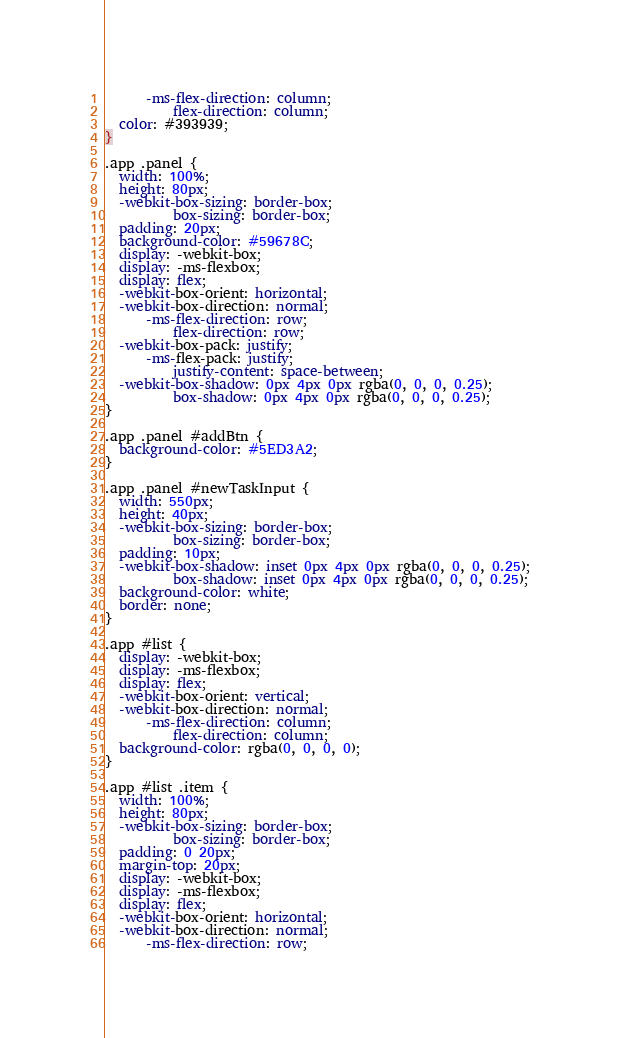<code> <loc_0><loc_0><loc_500><loc_500><_CSS_>      -ms-flex-direction: column;
          flex-direction: column;
  color: #393939;
}

.app .panel {
  width: 100%;
  height: 80px;
  -webkit-box-sizing: border-box;
          box-sizing: border-box;
  padding: 20px;
  background-color: #59678C;
  display: -webkit-box;
  display: -ms-flexbox;
  display: flex;
  -webkit-box-orient: horizontal;
  -webkit-box-direction: normal;
      -ms-flex-direction: row;
          flex-direction: row;
  -webkit-box-pack: justify;
      -ms-flex-pack: justify;
          justify-content: space-between;
  -webkit-box-shadow: 0px 4px 0px rgba(0, 0, 0, 0.25);
          box-shadow: 0px 4px 0px rgba(0, 0, 0, 0.25);
}

.app .panel #addBtn {
  background-color: #5ED3A2;
}

.app .panel #newTaskInput {
  width: 550px;
  height: 40px;
  -webkit-box-sizing: border-box;
          box-sizing: border-box;
  padding: 10px;
  -webkit-box-shadow: inset 0px 4px 0px rgba(0, 0, 0, 0.25);
          box-shadow: inset 0px 4px 0px rgba(0, 0, 0, 0.25);
  background-color: white;
  border: none;
}

.app #list {
  display: -webkit-box;
  display: -ms-flexbox;
  display: flex;
  -webkit-box-orient: vertical;
  -webkit-box-direction: normal;
      -ms-flex-direction: column;
          flex-direction: column;
  background-color: rgba(0, 0, 0, 0);
}

.app #list .item {
  width: 100%;
  height: 80px;
  -webkit-box-sizing: border-box;
          box-sizing: border-box;
  padding: 0 20px;
  margin-top: 20px;
  display: -webkit-box;
  display: -ms-flexbox;
  display: flex;
  -webkit-box-orient: horizontal;
  -webkit-box-direction: normal;
      -ms-flex-direction: row;</code> 